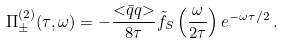Convert formula to latex. <formula><loc_0><loc_0><loc_500><loc_500>\Pi _ { \pm } ^ { ( 2 ) } ( \tau , \omega ) = - \frac { { < } \bar { q } q { > } } { 8 \tau } \tilde { f } _ { S } \left ( \frac { \omega } { 2 \tau } \right ) e ^ { - \omega \tau / 2 } \, .</formula> 